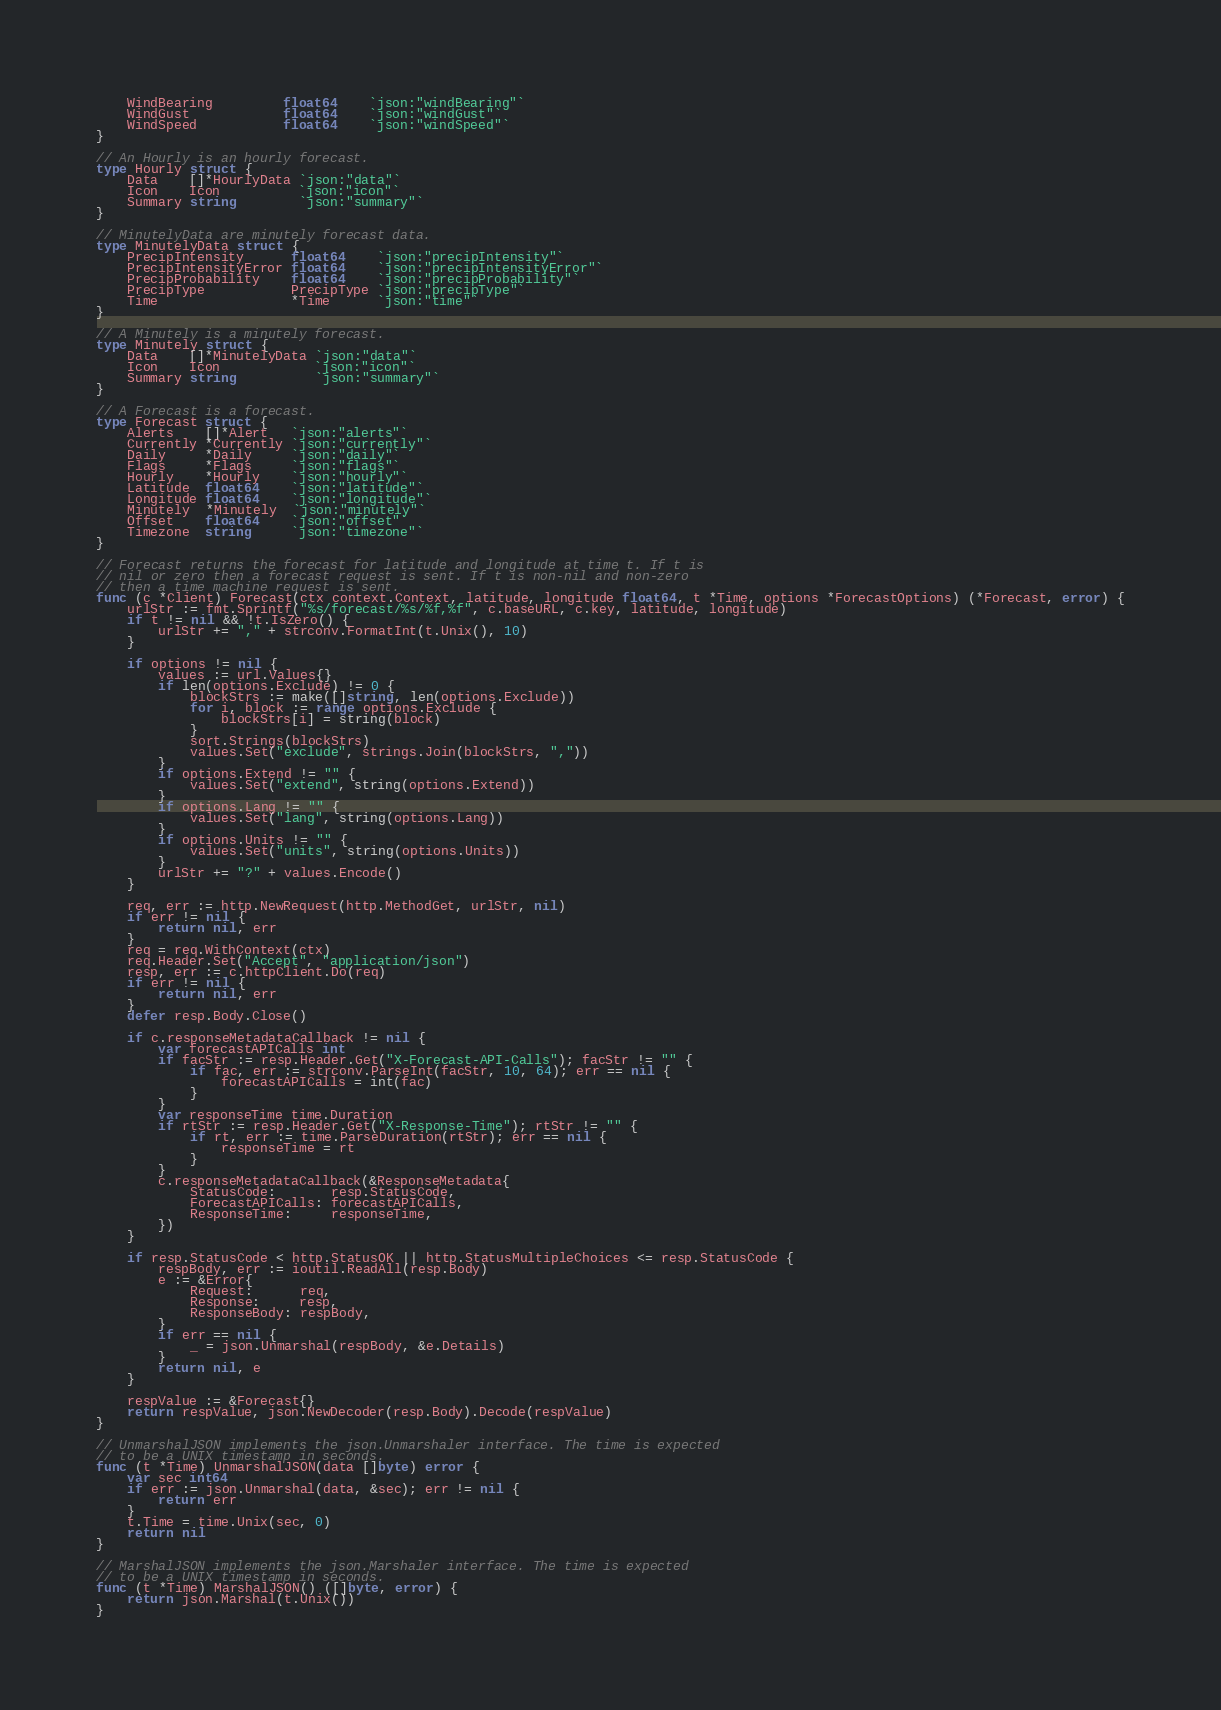<code> <loc_0><loc_0><loc_500><loc_500><_Go_>	WindBearing         float64    `json:"windBearing"`
	WindGust            float64    `json:"windGust"`
	WindSpeed           float64    `json:"windSpeed"`
}

// An Hourly is an hourly forecast.
type Hourly struct {
	Data    []*HourlyData `json:"data"`
	Icon    Icon          `json:"icon"`
	Summary string        `json:"summary"`
}

// MinutelyData are minutely forecast data.
type MinutelyData struct {
	PrecipIntensity      float64    `json:"precipIntensity"`
	PrecipIntensityError float64    `json:"precipIntensityError"`
	PrecipProbability    float64    `json:"precipProbability"`
	PrecipType           PrecipType `json:"precipType"`
	Time                 *Time      `json:"time"`
}

// A Minutely is a minutely forecast.
type Minutely struct {
	Data    []*MinutelyData `json:"data"`
	Icon    Icon            `json:"icon"`
	Summary string          `json:"summary"`
}

// A Forecast is a forecast.
type Forecast struct {
	Alerts    []*Alert   `json:"alerts"`
	Currently *Currently `json:"currently"`
	Daily     *Daily     `json:"daily"`
	Flags     *Flags     `json:"flags"`
	Hourly    *Hourly    `json:"hourly"`
	Latitude  float64    `json:"latitude"`
	Longitude float64    `json:"longitude"`
	Minutely  *Minutely  `json:"minutely"`
	Offset    float64    `json:"offset"`
	Timezone  string     `json:"timezone"`
}

// Forecast returns the forecast for latitude and longitude at time t. If t is
// nil or zero then a forecast request is sent. If t is non-nil and non-zero
// then a time machine request is sent.
func (c *Client) Forecast(ctx context.Context, latitude, longitude float64, t *Time, options *ForecastOptions) (*Forecast, error) {
	urlStr := fmt.Sprintf("%s/forecast/%s/%f,%f", c.baseURL, c.key, latitude, longitude)
	if t != nil && !t.IsZero() {
		urlStr += "," + strconv.FormatInt(t.Unix(), 10)
	}

	if options != nil {
		values := url.Values{}
		if len(options.Exclude) != 0 {
			blockStrs := make([]string, len(options.Exclude))
			for i, block := range options.Exclude {
				blockStrs[i] = string(block)
			}
			sort.Strings(blockStrs)
			values.Set("exclude", strings.Join(blockStrs, ","))
		}
		if options.Extend != "" {
			values.Set("extend", string(options.Extend))
		}
		if options.Lang != "" {
			values.Set("lang", string(options.Lang))
		}
		if options.Units != "" {
			values.Set("units", string(options.Units))
		}
		urlStr += "?" + values.Encode()
	}

	req, err := http.NewRequest(http.MethodGet, urlStr, nil)
	if err != nil {
		return nil, err
	}
	req = req.WithContext(ctx)
	req.Header.Set("Accept", "application/json")
	resp, err := c.httpClient.Do(req)
	if err != nil {
		return nil, err
	}
	defer resp.Body.Close()

	if c.responseMetadataCallback != nil {
		var forecastAPICalls int
		if facStr := resp.Header.Get("X-Forecast-API-Calls"); facStr != "" {
			if fac, err := strconv.ParseInt(facStr, 10, 64); err == nil {
				forecastAPICalls = int(fac)
			}
		}
		var responseTime time.Duration
		if rtStr := resp.Header.Get("X-Response-Time"); rtStr != "" {
			if rt, err := time.ParseDuration(rtStr); err == nil {
				responseTime = rt
			}
		}
		c.responseMetadataCallback(&ResponseMetadata{
			StatusCode:       resp.StatusCode,
			ForecastAPICalls: forecastAPICalls,
			ResponseTime:     responseTime,
		})
	}

	if resp.StatusCode < http.StatusOK || http.StatusMultipleChoices <= resp.StatusCode {
		respBody, err := ioutil.ReadAll(resp.Body)
		e := &Error{
			Request:      req,
			Response:     resp,
			ResponseBody: respBody,
		}
		if err == nil {
			_ = json.Unmarshal(respBody, &e.Details)
		}
		return nil, e
	}

	respValue := &Forecast{}
	return respValue, json.NewDecoder(resp.Body).Decode(respValue)
}

// UnmarshalJSON implements the json.Unmarshaler interface. The time is expected
// to be a UNIX timestamp in seconds.
func (t *Time) UnmarshalJSON(data []byte) error {
	var sec int64
	if err := json.Unmarshal(data, &sec); err != nil {
		return err
	}
	t.Time = time.Unix(sec, 0)
	return nil
}

// MarshalJSON implements the json.Marshaler interface. The time is expected
// to be a UNIX timestamp in seconds.
func (t *Time) MarshalJSON() ([]byte, error) {
	return json.Marshal(t.Unix())
}
</code> 